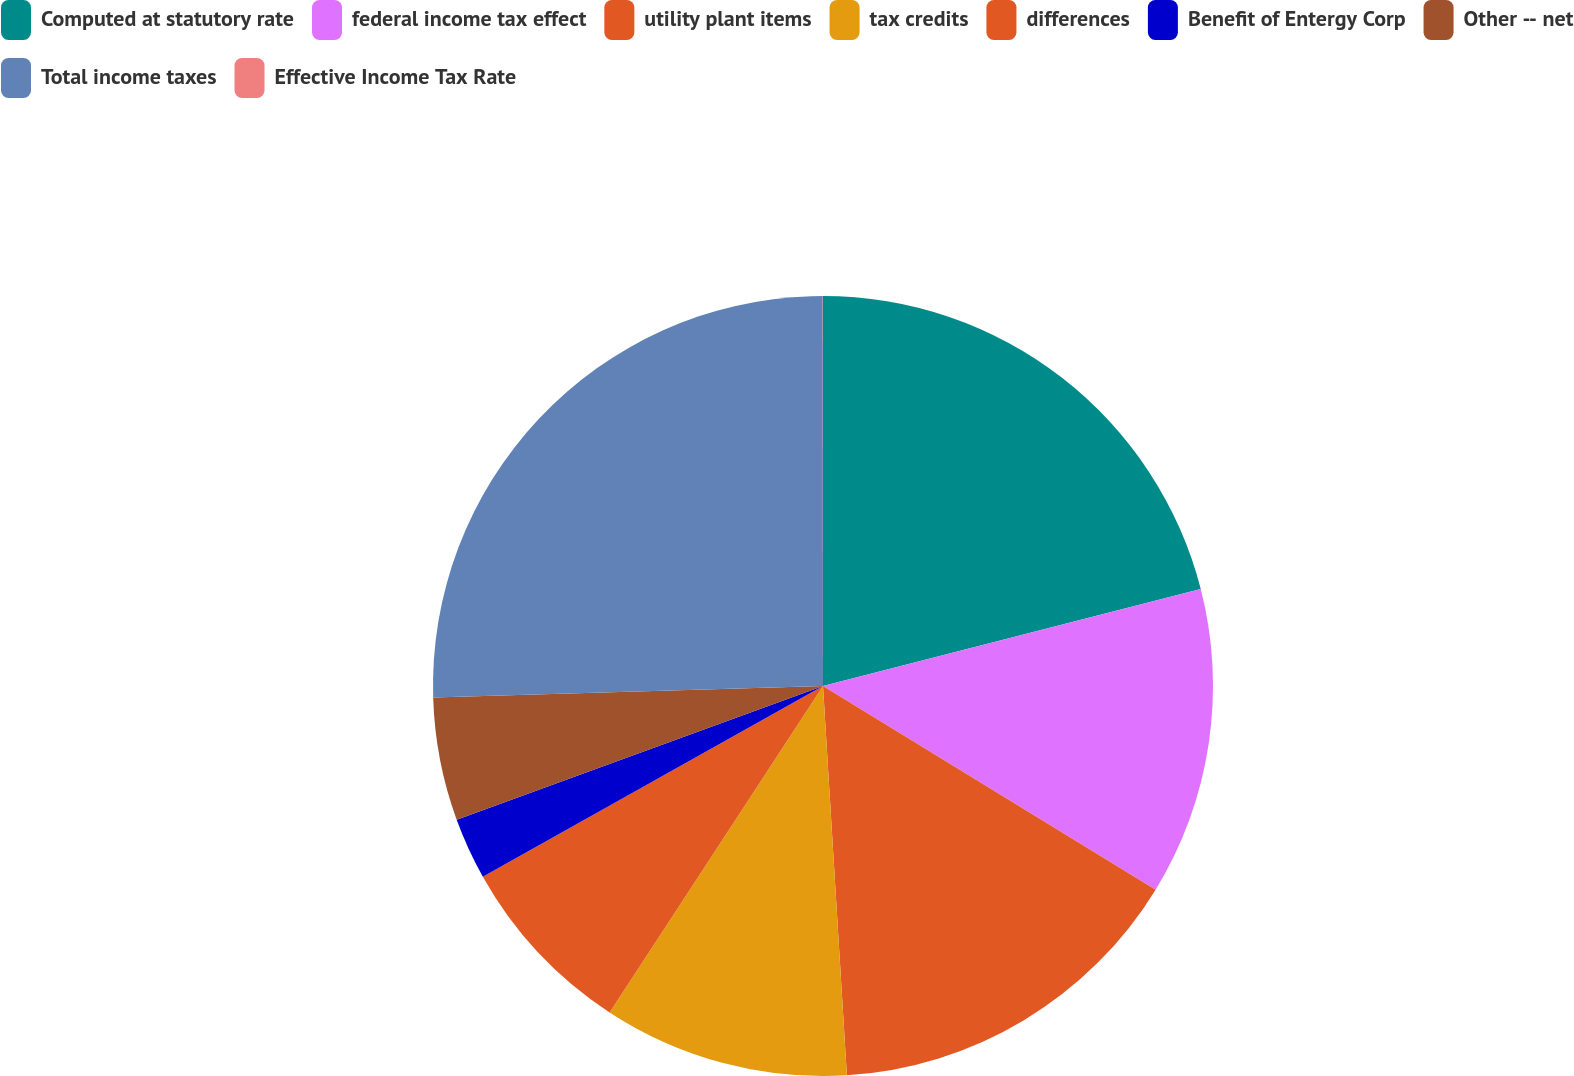<chart> <loc_0><loc_0><loc_500><loc_500><pie_chart><fcel>Computed at statutory rate<fcel>federal income tax effect<fcel>utility plant items<fcel>tax credits<fcel>differences<fcel>Benefit of Entergy Corp<fcel>Other -- net<fcel>Total income taxes<fcel>Effective Income Tax Rate<nl><fcel>21.0%<fcel>12.74%<fcel>15.28%<fcel>10.19%<fcel>7.65%<fcel>2.56%<fcel>5.1%<fcel>25.46%<fcel>0.01%<nl></chart> 